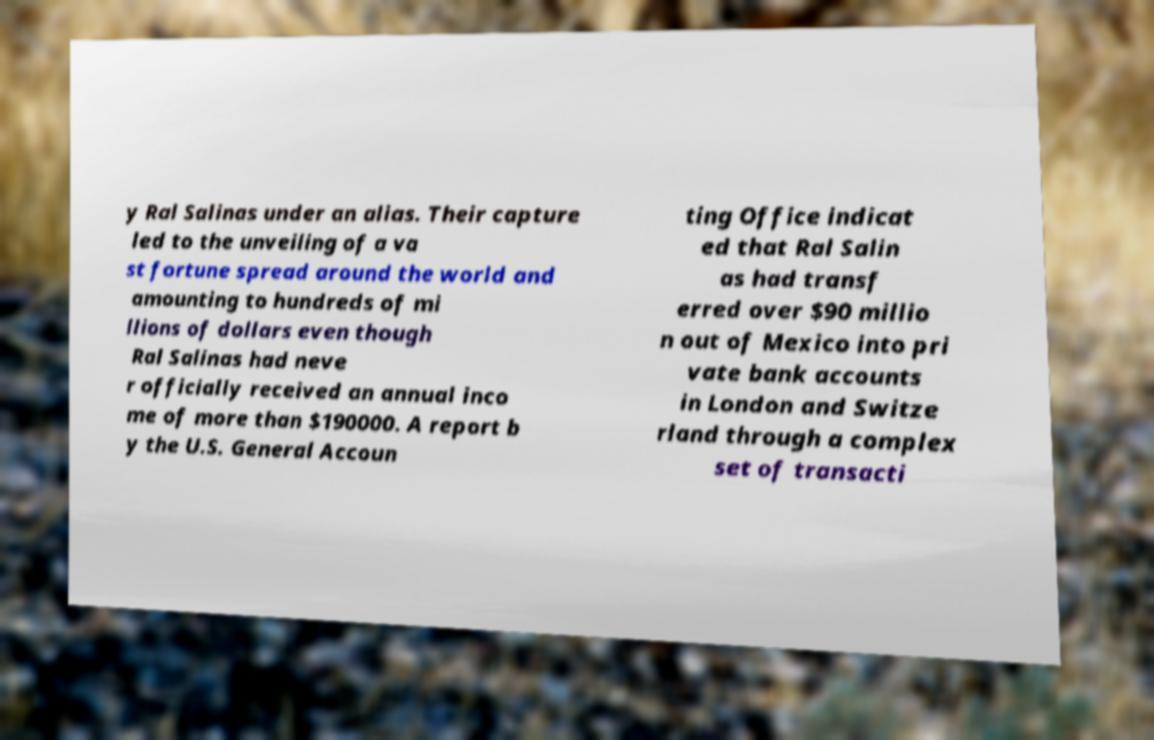Could you assist in decoding the text presented in this image and type it out clearly? y Ral Salinas under an alias. Their capture led to the unveiling of a va st fortune spread around the world and amounting to hundreds of mi llions of dollars even though Ral Salinas had neve r officially received an annual inco me of more than $190000. A report b y the U.S. General Accoun ting Office indicat ed that Ral Salin as had transf erred over $90 millio n out of Mexico into pri vate bank accounts in London and Switze rland through a complex set of transacti 